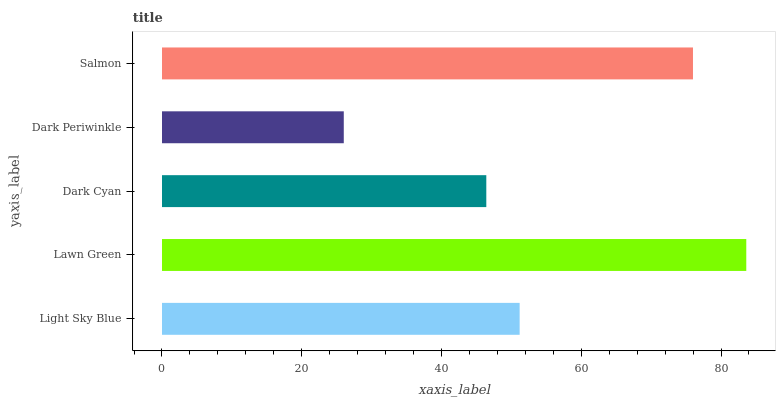Is Dark Periwinkle the minimum?
Answer yes or no. Yes. Is Lawn Green the maximum?
Answer yes or no. Yes. Is Dark Cyan the minimum?
Answer yes or no. No. Is Dark Cyan the maximum?
Answer yes or no. No. Is Lawn Green greater than Dark Cyan?
Answer yes or no. Yes. Is Dark Cyan less than Lawn Green?
Answer yes or no. Yes. Is Dark Cyan greater than Lawn Green?
Answer yes or no. No. Is Lawn Green less than Dark Cyan?
Answer yes or no. No. Is Light Sky Blue the high median?
Answer yes or no. Yes. Is Light Sky Blue the low median?
Answer yes or no. Yes. Is Dark Periwinkle the high median?
Answer yes or no. No. Is Lawn Green the low median?
Answer yes or no. No. 